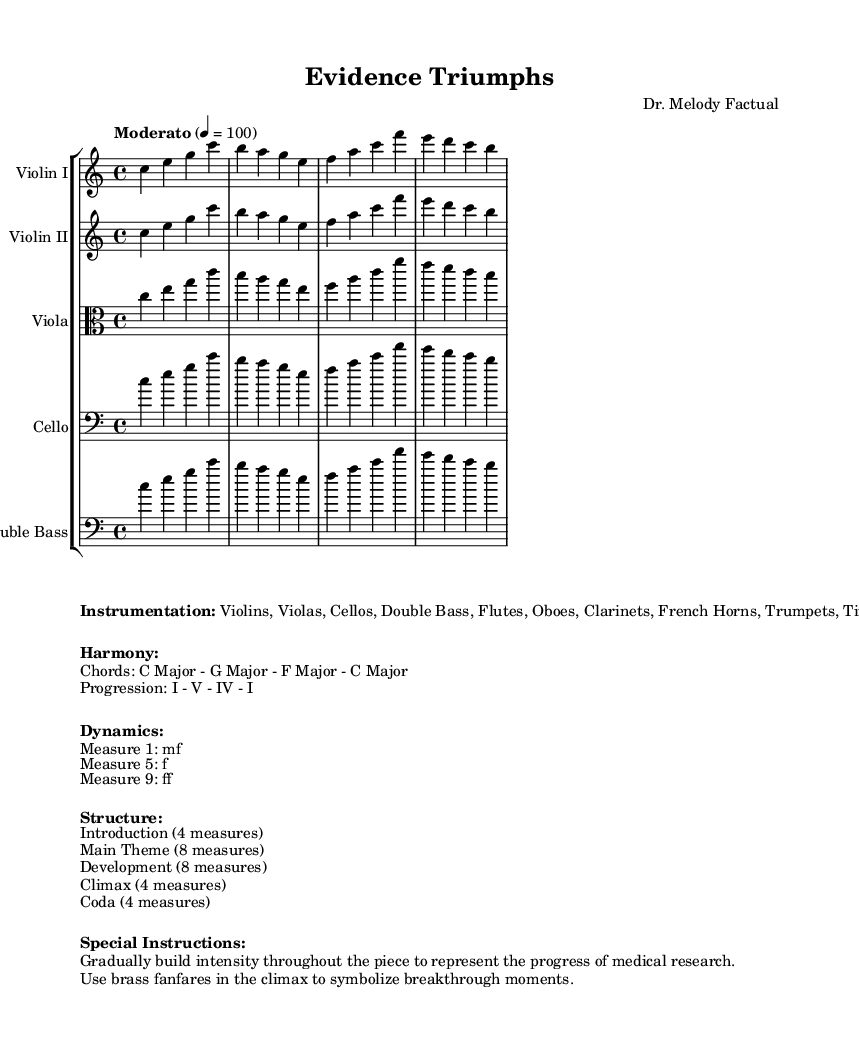What is the key signature of this music? The key signature is C major, which has no sharps or flats indicated. This is derived from the global context that specifies the key as C major.
Answer: C major What is the time signature of the piece? The time signature is 4/4, which is clearly indicated at the beginning of the global context. This means there are four beats in a measure, and a quarter note gets one beat.
Answer: 4/4 What is the tempo marking for the piece? The tempo marking is "Moderato," which suggests a moderate speed of 100 beats per minute, stated in the global context.
Answer: Moderato How many measures are in the introduction section? The introduction section contains 4 measures as clearly stated in the structural breakdown of the piece.
Answer: 4 measures What dynamics are indicated for measure 5? The dynamics for measure 5 are indicated as "f," meaning forte or loud. This is specified in the dynamics section of the markup.
Answer: f What instruments are included in the orchestral arrangement? The instrumentation includes Violins, Violas, Cellos, Double Bass, Flutes, Oboes, Clarinets, French Horns, Trumpets, and Timpani, as listed in the markup section under instrumentation.
Answer: Violins, Violas, Cellos, Double Bass, Flutes, Oboes, Clarinets, French Horns, Trumpets, Timpani What does the climax of the piece symbolize? The climax of the piece symbolizes breakthrough moments, as explained in the special instructions which suggest using brass fanfares at this part of the composition to represent significant advances in medical research.
Answer: Breakthrough moments 